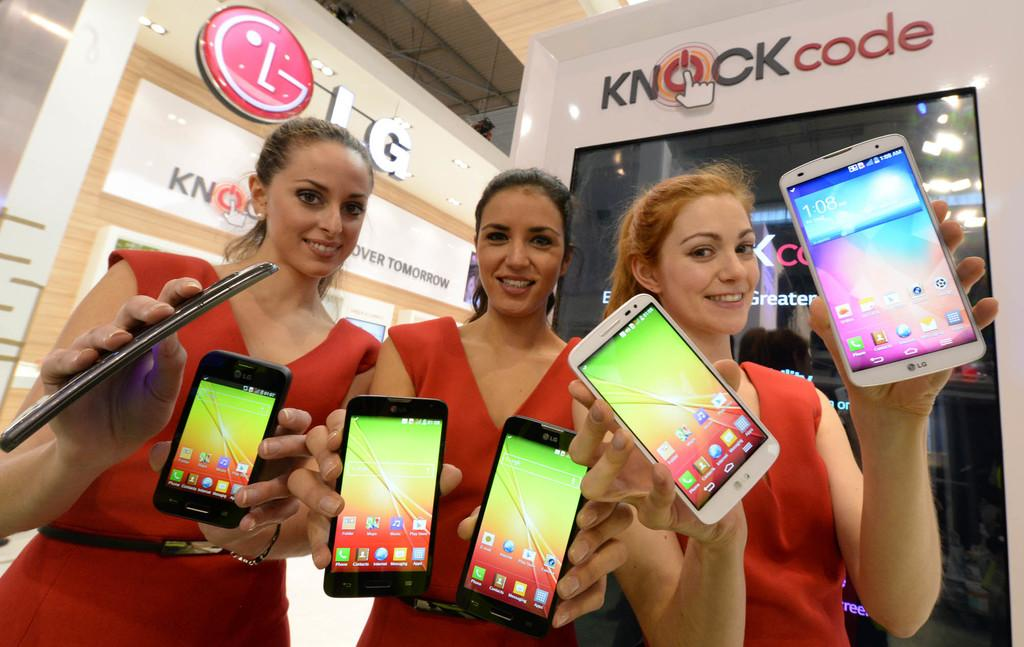How many ladies are present in the image? There are three ladies in the image. What are the ladies wearing? The ladies are wearing red dresses. What are the ladies holding in their hands? The ladies are holding mobiles in their hands. What can be seen in the background of the image? There is a board in the background of the image. What is written or displayed on the board? There is some text on the board. Is there a hospital visible in the image? No, there is no hospital present in the image. Do the ladies in the image need to get approval from someone before they can use their mobiles? There is no indication in the image that the ladies need approval to use their mobiles. 